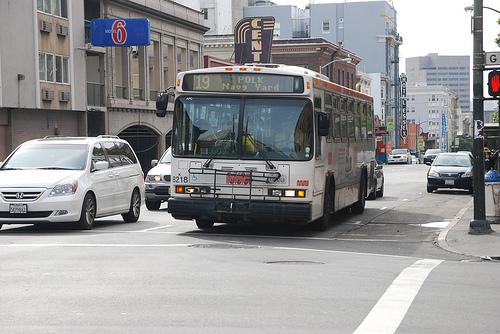Question: what does the bus say?
Choices:
A. North West Ave.
B. "Polk Navy Yard.".
C. South East Blvd.
D. West Green Street.
Answer with the letter. Answer: B 